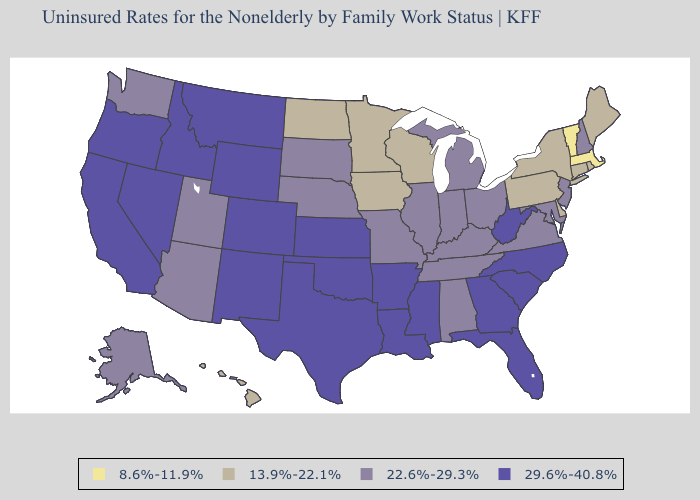Name the states that have a value in the range 22.6%-29.3%?
Give a very brief answer. Alabama, Alaska, Arizona, Illinois, Indiana, Kentucky, Maryland, Michigan, Missouri, Nebraska, New Hampshire, New Jersey, Ohio, South Dakota, Tennessee, Utah, Virginia, Washington. Does Alabama have the highest value in the South?
Quick response, please. No. Name the states that have a value in the range 29.6%-40.8%?
Write a very short answer. Arkansas, California, Colorado, Florida, Georgia, Idaho, Kansas, Louisiana, Mississippi, Montana, Nevada, New Mexico, North Carolina, Oklahoma, Oregon, South Carolina, Texas, West Virginia, Wyoming. What is the highest value in the USA?
Short answer required. 29.6%-40.8%. Does California have the lowest value in the West?
Be succinct. No. What is the lowest value in the MidWest?
Short answer required. 13.9%-22.1%. What is the lowest value in the South?
Concise answer only. 13.9%-22.1%. Does Kansas have the lowest value in the MidWest?
Keep it brief. No. What is the value of North Carolina?
Be succinct. 29.6%-40.8%. Does Oklahoma have the same value as Connecticut?
Short answer required. No. Does Maryland have the highest value in the South?
Concise answer only. No. Name the states that have a value in the range 22.6%-29.3%?
Keep it brief. Alabama, Alaska, Arizona, Illinois, Indiana, Kentucky, Maryland, Michigan, Missouri, Nebraska, New Hampshire, New Jersey, Ohio, South Dakota, Tennessee, Utah, Virginia, Washington. Which states have the highest value in the USA?
Give a very brief answer. Arkansas, California, Colorado, Florida, Georgia, Idaho, Kansas, Louisiana, Mississippi, Montana, Nevada, New Mexico, North Carolina, Oklahoma, Oregon, South Carolina, Texas, West Virginia, Wyoming. Which states have the lowest value in the South?
Give a very brief answer. Delaware. What is the lowest value in the MidWest?
Give a very brief answer. 13.9%-22.1%. 